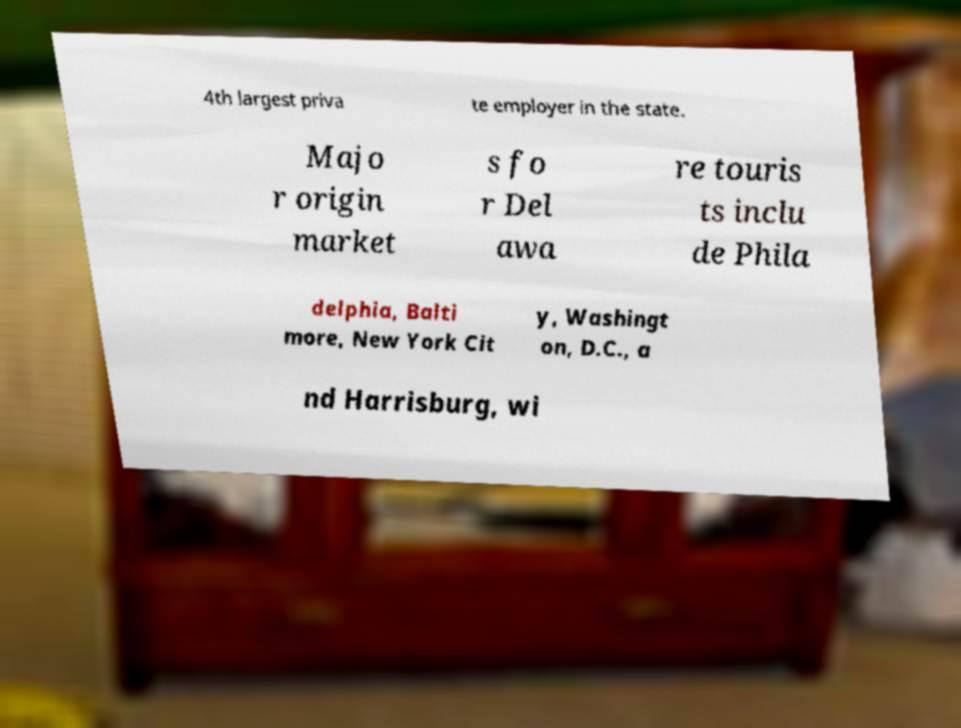Please identify and transcribe the text found in this image. 4th largest priva te employer in the state. Majo r origin market s fo r Del awa re touris ts inclu de Phila delphia, Balti more, New York Cit y, Washingt on, D.C., a nd Harrisburg, wi 